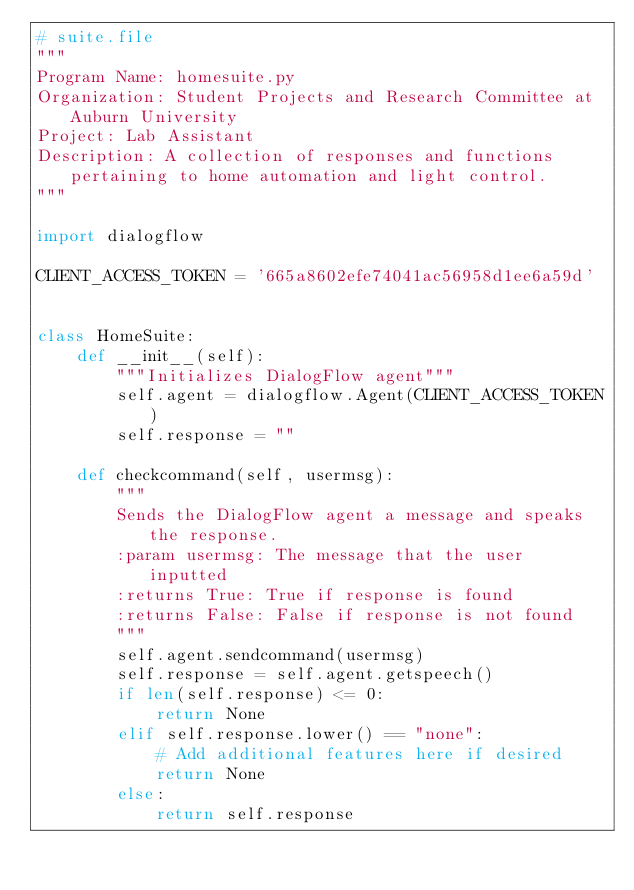<code> <loc_0><loc_0><loc_500><loc_500><_Python_># suite.file
"""
Program Name: homesuite.py
Organization: Student Projects and Research Committee at Auburn University
Project: Lab Assistant
Description: A collection of responses and functions pertaining to home automation and light control.
"""

import dialogflow

CLIENT_ACCESS_TOKEN = '665a8602efe74041ac56958d1ee6a59d'


class HomeSuite:
    def __init__(self):
        """Initializes DialogFlow agent"""
        self.agent = dialogflow.Agent(CLIENT_ACCESS_TOKEN)
        self.response = ""

    def checkcommand(self, usermsg):
        """
        Sends the DialogFlow agent a message and speaks the response.
        :param usermsg: The message that the user inputted
        :returns True: True if response is found
        :returns False: False if response is not found
        """
        self.agent.sendcommand(usermsg)
        self.response = self.agent.getspeech()
        if len(self.response) <= 0:
            return None
        elif self.response.lower() == "none":
            # Add additional features here if desired
            return None
        else:
            return self.response
</code> 